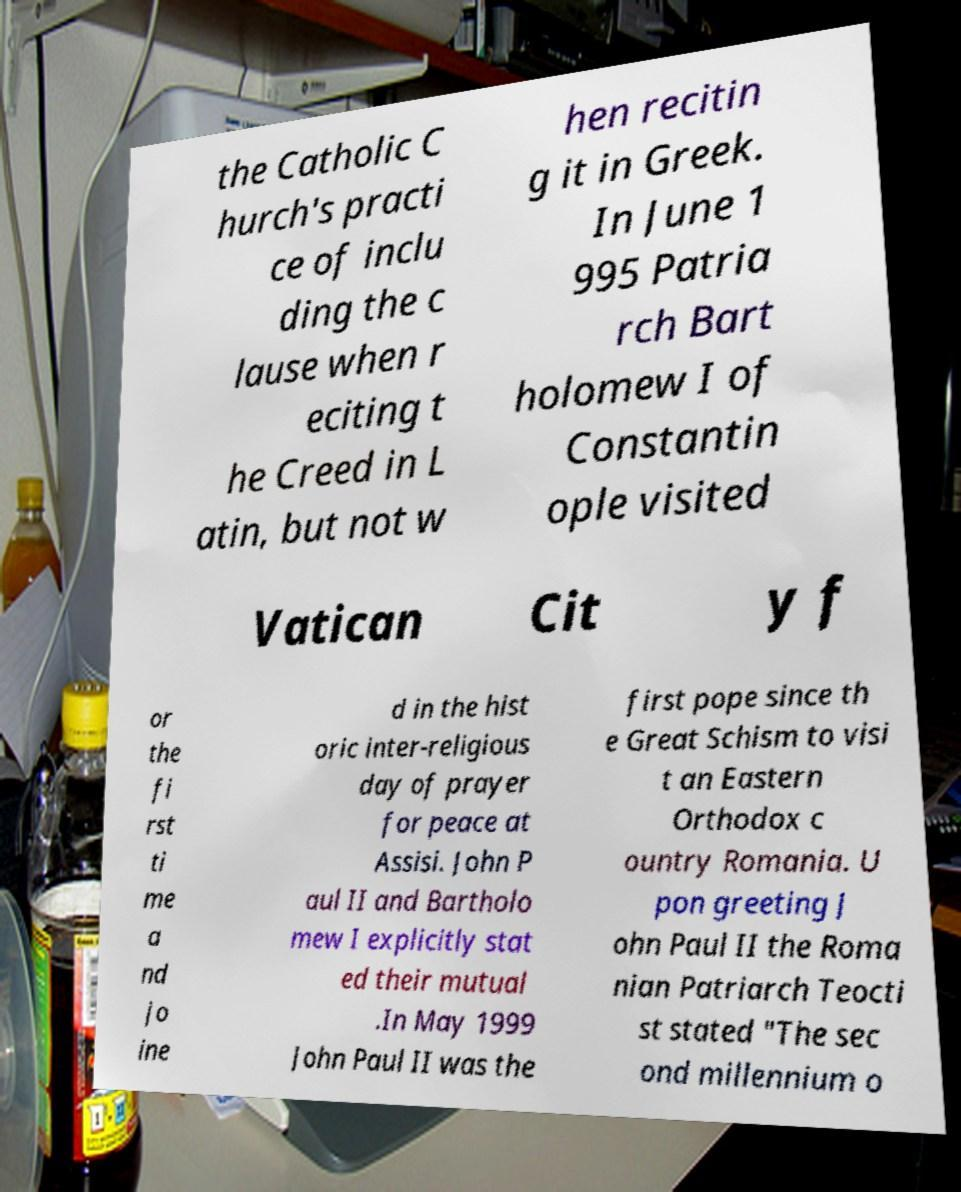I need the written content from this picture converted into text. Can you do that? the Catholic C hurch's practi ce of inclu ding the c lause when r eciting t he Creed in L atin, but not w hen recitin g it in Greek. In June 1 995 Patria rch Bart holomew I of Constantin ople visited Vatican Cit y f or the fi rst ti me a nd jo ine d in the hist oric inter-religious day of prayer for peace at Assisi. John P aul II and Bartholo mew I explicitly stat ed their mutual .In May 1999 John Paul II was the first pope since th e Great Schism to visi t an Eastern Orthodox c ountry Romania. U pon greeting J ohn Paul II the Roma nian Patriarch Teocti st stated "The sec ond millennium o 